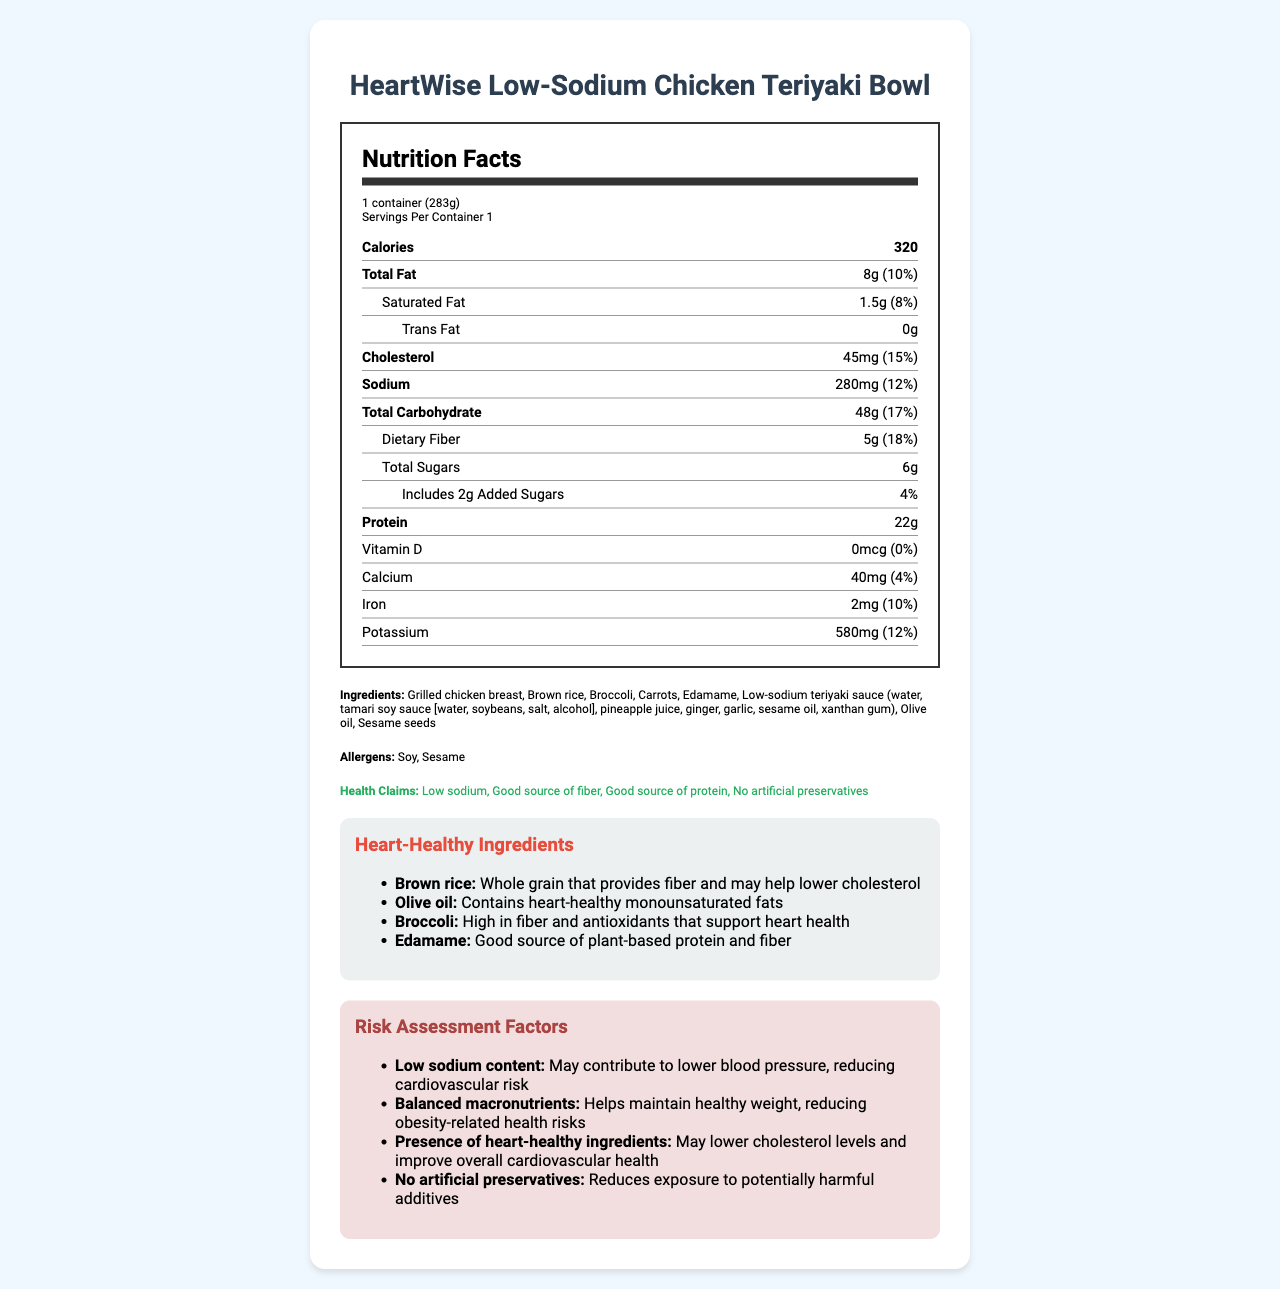what is the serving size for the HeartWise Low-Sodium Chicken Teriyaki Bowl? The serving size is explicitly stated in the document as "1 container (283g)".
Answer: 1 container (283g) how many calories are in one serving? The document specifies that each serving contains 320 calories.
Answer: 320 what is the amount of total fat per serving? The total fat per serving is listed as 8g in the nutrition facts section of the document.
Answer: 8g what are the heart-healthy ingredients listed in the document? The document lists these as the heart-healthy ingredients along with their respective benefits.
Answer: Brown rice, Olive oil, Broccoli, Edamame what allergens are present in this product? The allergens section mentions soy and sesame as present in the product.
Answer: Soy, Sesame The HeartWise Low-Sodium Chicken Teriyaki Bowl contains how much dietary fiber? A. 1g B. 5g C. 10g The nutrition facts clearly state that the dietary fiber per serving is 5g.
Answer: B Which of the following is a health claim made for this product? I. Low sodium II. Contains artificial preservatives III. Good source of protein The health claims section mentions "Low sodium" and "Good source of protein", but does not mention containing artificial preservatives.
Answer: I and III Is the product a good source of dietary fiber? The product provides 5g of dietary fiber per serving with an 18% daily value, indicating it is a good source of dietary fiber.
Answer: Yes Summarize the main health benefits and claims of the HeartWise Low-Sodium Chicken Teriyaki Bowl. The document outlines these points through the heart-healthy ingredients, nutrition facts, and health claims sections.
Answer: The HeartWise Low-Sodium Chicken Teriyaki Bowl is a low-sodium meal that is a good source of fiber and protein. It contains heart-healthy ingredients such as brown rice, olive oil, broccoli, and edamame that contribute to lower cholesterol and better cardiovascular health. The meal is also free from artificial preservatives. What are the potential cardiovascular benefits of consuming this product? The risk assessment factors and heart-healthy ingredients sections explain the cardiovascular benefits, such as low sodium content for blood pressure and heart-healthy fats and fiber for cholesterol and heart health.
Answer: It may contribute to lower blood pressure and cholesterol levels, improving overall cardiovascular health. What is the impact of the low sodium content in this meal? The risk assessment factors clearly state that low sodium content may help lower blood pressure, thereby reducing cardiovascular risk.
Answer: May contribute to lower blood pressure, reducing cardiovascular risk How much Vitamin D does the HeartWise Low-Sodium Chicken Teriyaki Bowl provide? The nutrition facts indicate that there is 0mcg of Vitamin D in the product.
Answer: 0mcg What is the daily value percentage of calcium provided by one serving? The document states that the product provides 40mg of calcium, which is 4% of the daily value.
Answer: 4% What kind of fiber source is included in the HeartWise Low-Sodium Chicken Teriyaki Bowl? The heart-healthy ingredients section mentions brown rice and broccoli as sources of fiber.
Answer: Brown rice and broccoli Which ingredient in the HeartWise Low-Sodium Chicken Teriyaki Bowl provides plant-based protein? The heart-healthy ingredients section lists edamame as a good source of plant-based protein.
Answer: Edamame What is the exact amount of added sugars in this product? The nutrition facts specify that there are 2g of added sugars in the HeartWise Low-Sodium Chicken Teriyaki Bowl.
Answer: 2g What is the purpose of xanthan gum in the low-sodium teriyaki sauce? The document lists xanthan gum as an ingredient, but it does not specify its purpose.
Answer: Cannot be determined 